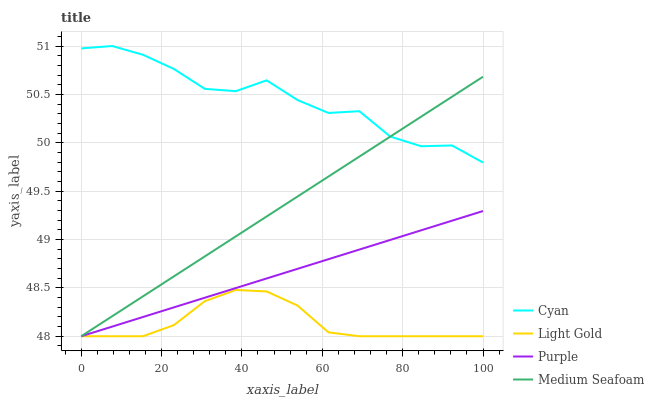Does Cyan have the minimum area under the curve?
Answer yes or no. No. Does Light Gold have the maximum area under the curve?
Answer yes or no. No. Is Light Gold the smoothest?
Answer yes or no. No. Is Light Gold the roughest?
Answer yes or no. No. Does Cyan have the lowest value?
Answer yes or no. No. Does Light Gold have the highest value?
Answer yes or no. No. Is Purple less than Cyan?
Answer yes or no. Yes. Is Cyan greater than Purple?
Answer yes or no. Yes. Does Purple intersect Cyan?
Answer yes or no. No. 